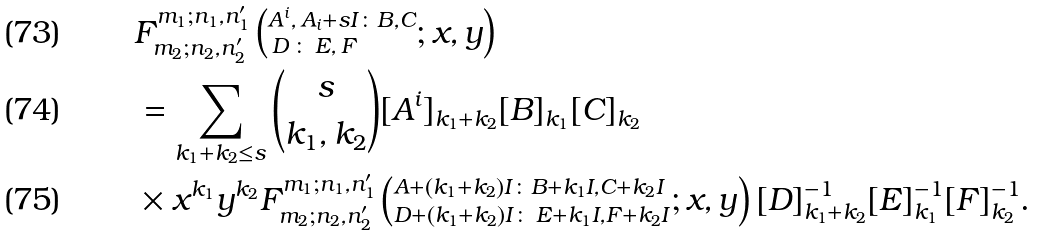<formula> <loc_0><loc_0><loc_500><loc_500>& F ^ { m _ { 1 } ; n _ { 1 } , n ^ { \prime } _ { 1 } } _ { m _ { 2 } ; n _ { 2 } , n ^ { \prime } _ { 2 } } \left ( ^ { A ^ { i } , \, A _ { i } + s I \colon B , C } _ { \, D \, \colon \, E , \, F } ; x , y \right ) \\ & = \sum _ { k _ { 1 } + k _ { 2 } \leq s } { s \choose k _ { 1 } , k _ { 2 } } { [ A ^ { i } ] _ { k _ { 1 } + k _ { 2 } } [ B ] _ { k _ { 1 } } } [ C ] _ { k _ { 2 } } \, \\ & \times x ^ { k _ { 1 } } y ^ { k _ { 2 } } F ^ { m _ { 1 } ; n _ { 1 } , n ^ { \prime } _ { 1 } } _ { m _ { 2 } ; n _ { 2 } , n ^ { \prime } _ { 2 } } \left ( ^ { A + ( k _ { 1 } + k _ { 2 } ) I \colon B + k _ { 1 } I , C + k _ { 2 } I } _ { D + ( k _ { 1 } + k _ { 2 } ) I \colon \, E + k _ { 1 } I , F + k _ { 2 } I } ; x , y \right ) { [ D ] ^ { - 1 } _ { k _ { 1 } + k _ { 2 } } [ E ] ^ { - 1 } _ { k _ { 1 } } [ F ] ^ { - 1 } _ { k _ { 2 } } } .</formula> 